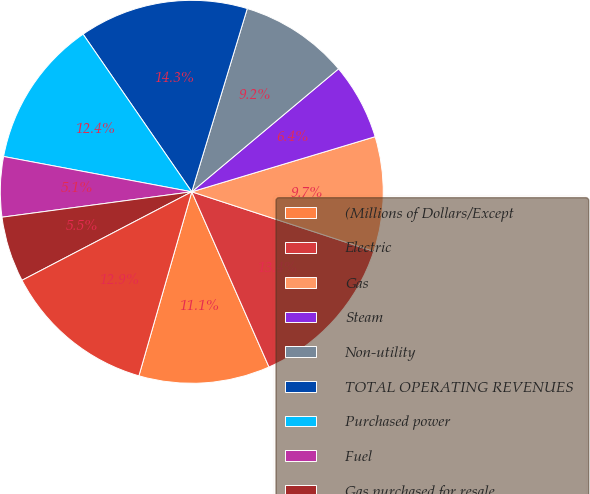<chart> <loc_0><loc_0><loc_500><loc_500><pie_chart><fcel>(Millions of Dollars/Except<fcel>Electric<fcel>Gas<fcel>Steam<fcel>Non-utility<fcel>TOTAL OPERATING REVENUES<fcel>Purchased power<fcel>Fuel<fcel>Gas purchased for resale<fcel>Other operations and<nl><fcel>11.06%<fcel>13.36%<fcel>9.68%<fcel>6.45%<fcel>9.22%<fcel>14.29%<fcel>12.44%<fcel>5.07%<fcel>5.53%<fcel>12.9%<nl></chart> 